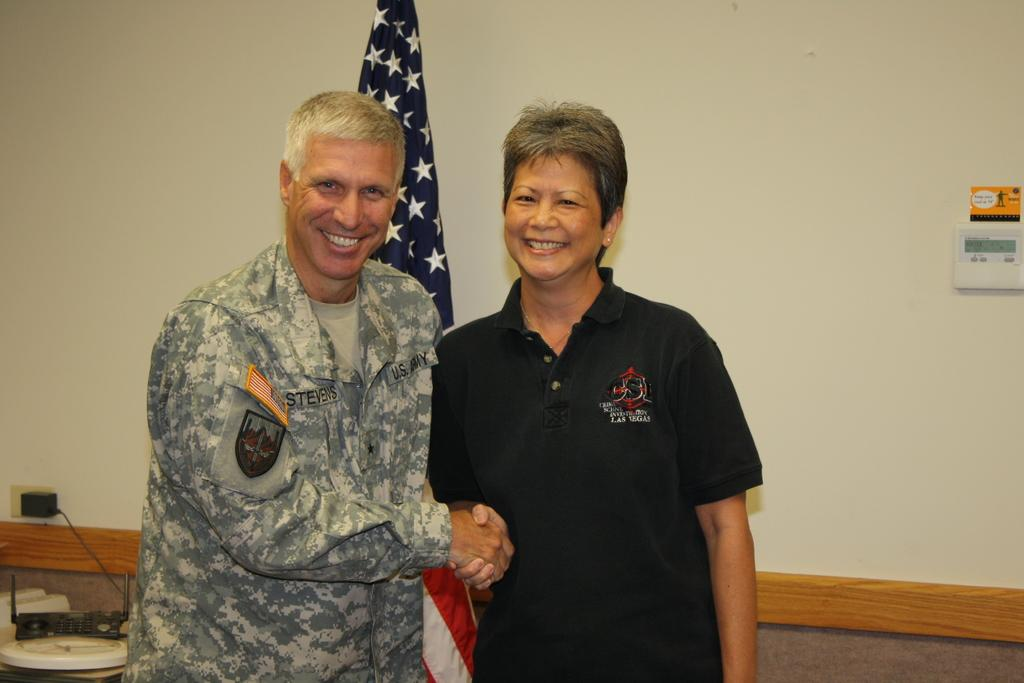Who are the two people in the image? There is a man and a woman in the image. What are the man and woman doing in the image? The man and woman are shaking hands. What can be seen in the background of the image? There is a table, objects on the table, a flag, and a wall in the background of the image. What is the amount of zinc present in the image? There is no mention of zinc in the image, so it is not possible to determine the amount of zinc present. 